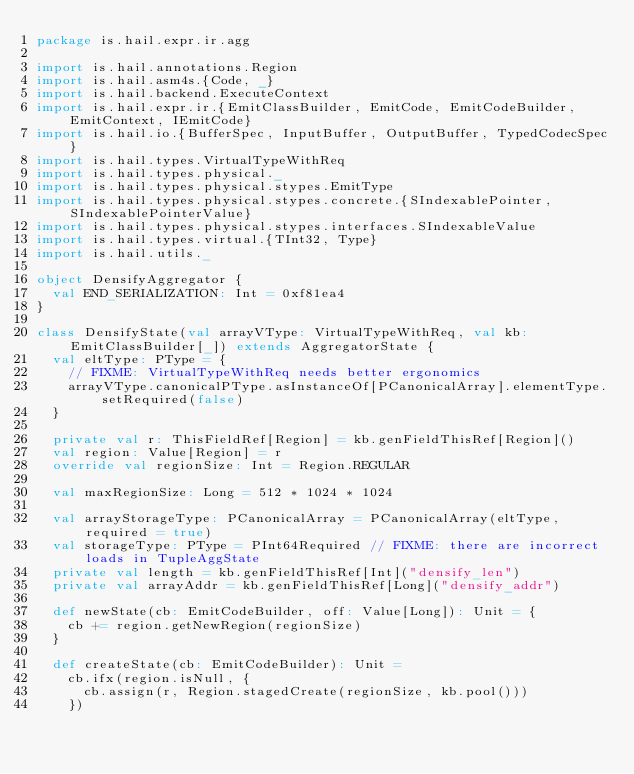<code> <loc_0><loc_0><loc_500><loc_500><_Scala_>package is.hail.expr.ir.agg

import is.hail.annotations.Region
import is.hail.asm4s.{Code, _}
import is.hail.backend.ExecuteContext
import is.hail.expr.ir.{EmitClassBuilder, EmitCode, EmitCodeBuilder, EmitContext, IEmitCode}
import is.hail.io.{BufferSpec, InputBuffer, OutputBuffer, TypedCodecSpec}
import is.hail.types.VirtualTypeWithReq
import is.hail.types.physical._
import is.hail.types.physical.stypes.EmitType
import is.hail.types.physical.stypes.concrete.{SIndexablePointer, SIndexablePointerValue}
import is.hail.types.physical.stypes.interfaces.SIndexableValue
import is.hail.types.virtual.{TInt32, Type}
import is.hail.utils._

object DensifyAggregator {
  val END_SERIALIZATION: Int = 0xf81ea4
}

class DensifyState(val arrayVType: VirtualTypeWithReq, val kb: EmitClassBuilder[_]) extends AggregatorState {
  val eltType: PType = {
    // FIXME: VirtualTypeWithReq needs better ergonomics
    arrayVType.canonicalPType.asInstanceOf[PCanonicalArray].elementType.setRequired(false)
  }

  private val r: ThisFieldRef[Region] = kb.genFieldThisRef[Region]()
  val region: Value[Region] = r
  override val regionSize: Int = Region.REGULAR

  val maxRegionSize: Long = 512 * 1024 * 1024

  val arrayStorageType: PCanonicalArray = PCanonicalArray(eltType, required = true)
  val storageType: PType = PInt64Required // FIXME: there are incorrect loads in TupleAggState
  private val length = kb.genFieldThisRef[Int]("densify_len")
  private val arrayAddr = kb.genFieldThisRef[Long]("densify_addr")

  def newState(cb: EmitCodeBuilder, off: Value[Long]): Unit = {
    cb += region.getNewRegion(regionSize)
  }

  def createState(cb: EmitCodeBuilder): Unit =
    cb.ifx(region.isNull, {
      cb.assign(r, Region.stagedCreate(regionSize, kb.pool()))
    })
</code> 